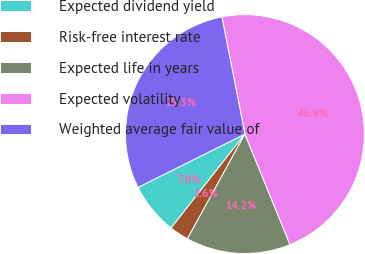<chart> <loc_0><loc_0><loc_500><loc_500><pie_chart><fcel>Expected dividend yield<fcel>Risk-free interest rate<fcel>Expected life in years<fcel>Expected volatility<fcel>Weighted average fair value of<nl><fcel>7.04%<fcel>2.61%<fcel>14.16%<fcel>46.92%<fcel>29.27%<nl></chart> 